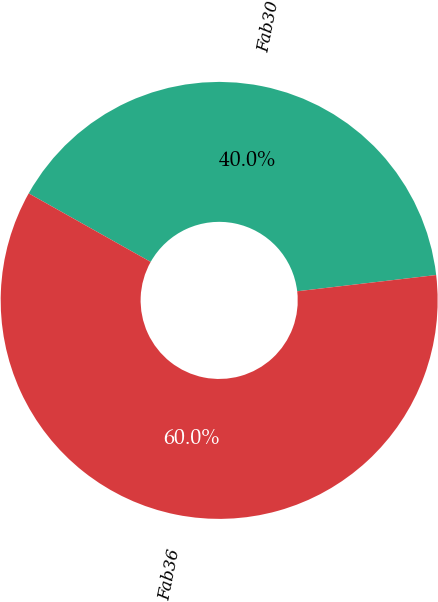Convert chart to OTSL. <chart><loc_0><loc_0><loc_500><loc_500><pie_chart><fcel>Fab30<fcel>Fab36<nl><fcel>40.0%<fcel>60.0%<nl></chart> 